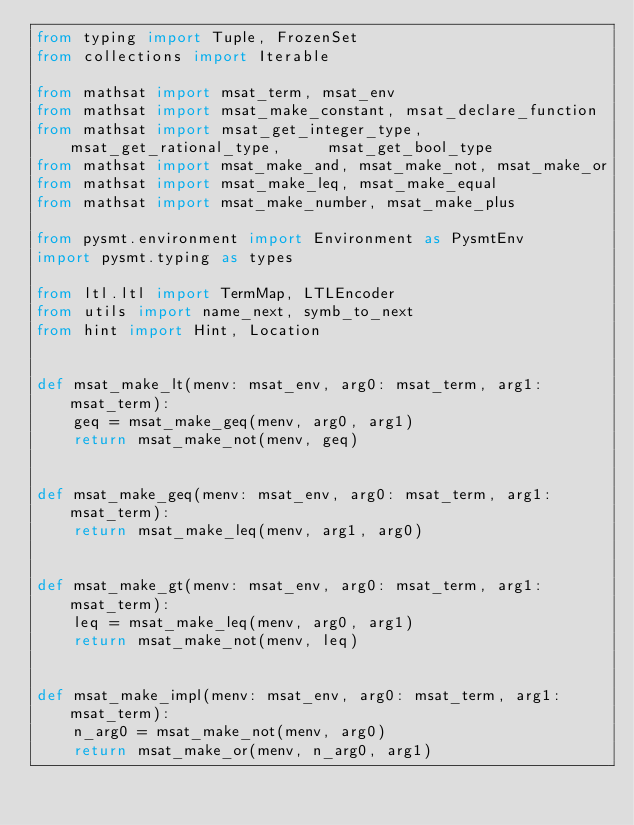<code> <loc_0><loc_0><loc_500><loc_500><_Python_>from typing import Tuple, FrozenSet
from collections import Iterable

from mathsat import msat_term, msat_env
from mathsat import msat_make_constant, msat_declare_function
from mathsat import msat_get_integer_type, msat_get_rational_type,     msat_get_bool_type
from mathsat import msat_make_and, msat_make_not, msat_make_or
from mathsat import msat_make_leq, msat_make_equal
from mathsat import msat_make_number, msat_make_plus

from pysmt.environment import Environment as PysmtEnv
import pysmt.typing as types

from ltl.ltl import TermMap, LTLEncoder
from utils import name_next, symb_to_next
from hint import Hint, Location


def msat_make_lt(menv: msat_env, arg0: msat_term, arg1: msat_term):
    geq = msat_make_geq(menv, arg0, arg1)
    return msat_make_not(menv, geq)


def msat_make_geq(menv: msat_env, arg0: msat_term, arg1: msat_term):
    return msat_make_leq(menv, arg1, arg0)


def msat_make_gt(menv: msat_env, arg0: msat_term, arg1: msat_term):
    leq = msat_make_leq(menv, arg0, arg1)
    return msat_make_not(menv, leq)


def msat_make_impl(menv: msat_env, arg0: msat_term, arg1: msat_term):
    n_arg0 = msat_make_not(menv, arg0)
    return msat_make_or(menv, n_arg0, arg1)

</code> 